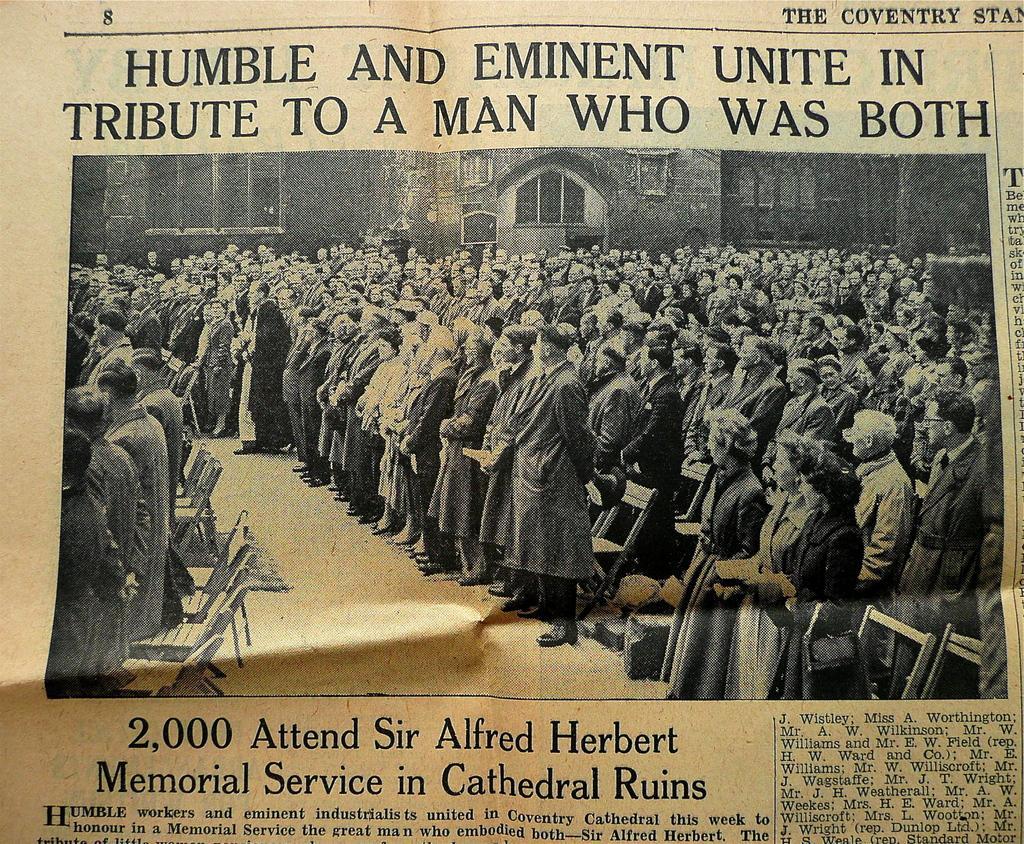Could you give a brief overview of what you see in this image? In this picture I can see there are a huge number of people standing and there are few chairs behind them. IN the backdrop there is a building and a window. There is something written at the top and bottom of the image and this is a news paper article. 